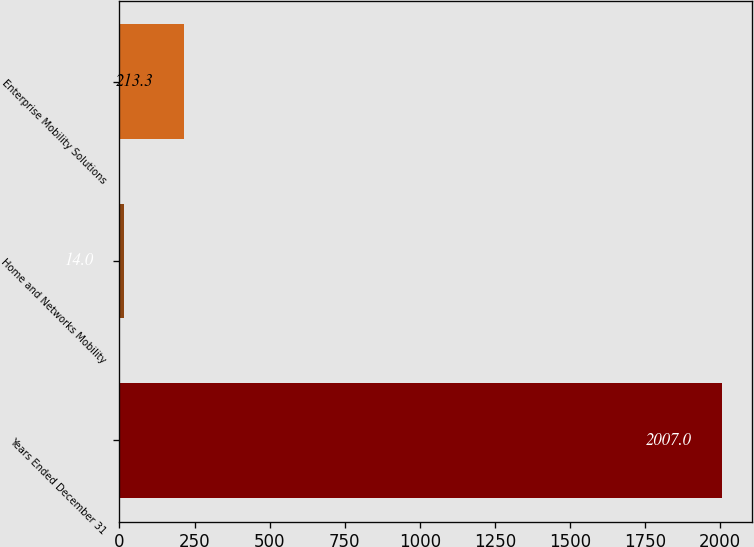Convert chart to OTSL. <chart><loc_0><loc_0><loc_500><loc_500><bar_chart><fcel>Years Ended December 31<fcel>Home and Networks Mobility<fcel>Enterprise Mobility Solutions<nl><fcel>2007<fcel>14<fcel>213.3<nl></chart> 